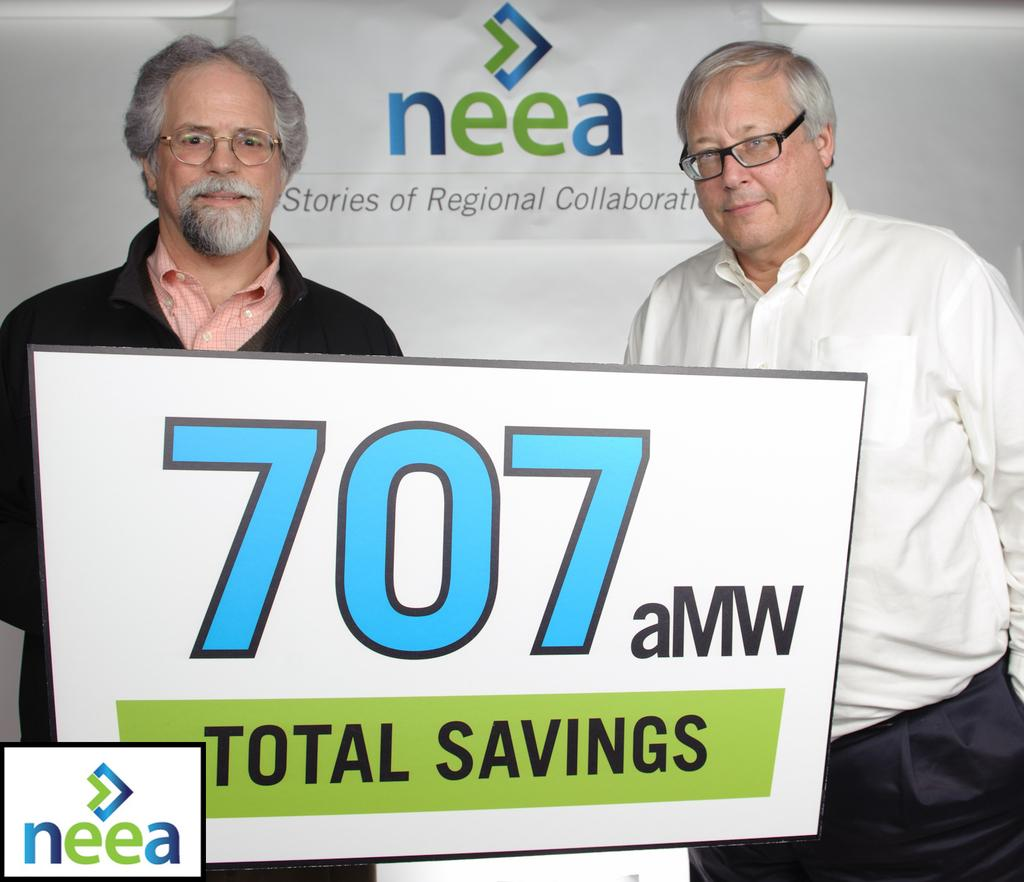How many people are in the image? There are two persons in the image. What are the two persons doing in the image? The two persons are standing behind an advertisement. Can you describe the background of the image? There is a wall with an advertisement in the background of the image. What type of milk is being advertised on the wall in the image? There is no milk or any reference to milk in the image; it features an advertisement, but the content of the advertisement is not specified. 